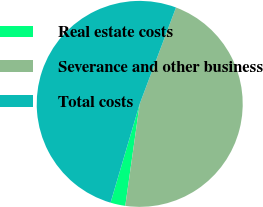Convert chart to OTSL. <chart><loc_0><loc_0><loc_500><loc_500><pie_chart><fcel>Real estate costs<fcel>Severance and other business<fcel>Total costs<nl><fcel>2.33%<fcel>46.51%<fcel>51.16%<nl></chart> 